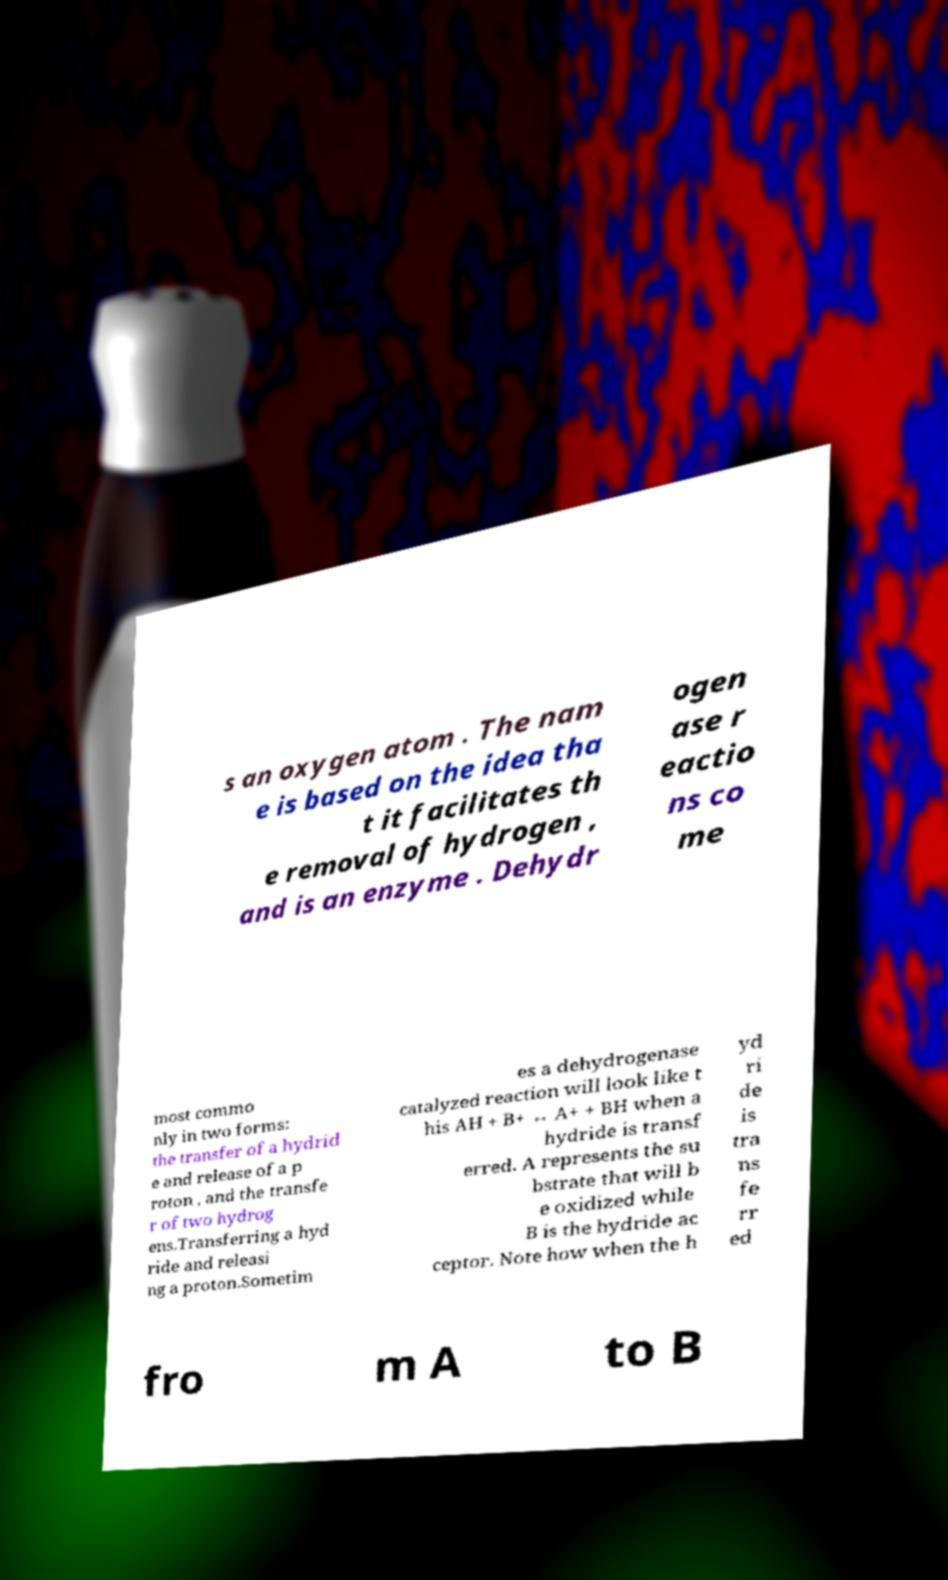There's text embedded in this image that I need extracted. Can you transcribe it verbatim? s an oxygen atom . The nam e is based on the idea tha t it facilitates th e removal of hydrogen , and is an enzyme . Dehydr ogen ase r eactio ns co me most commo nly in two forms: the transfer of a hydrid e and release of a p roton , and the transfe r of two hydrog ens.Transferring a hyd ride and releasi ng a proton.Sometim es a dehydrogenase catalyzed reaction will look like t his AH + B+ ↔ A+ + BH when a hydride is transf erred. A represents the su bstrate that will b e oxidized while B is the hydride ac ceptor. Note how when the h yd ri de is tra ns fe rr ed fro m A to B 